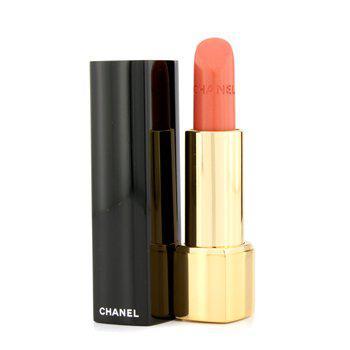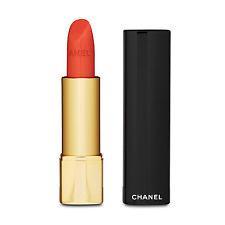The first image is the image on the left, the second image is the image on the right. Examine the images to the left and right. Is the description "There are more than one lipsticks in one of the images." accurate? Answer yes or no. No. The first image is the image on the left, the second image is the image on the right. Given the left and right images, does the statement "One image contains a single lipstick next to its lid, and the other image contains multiple lipsticks next to their lids." hold true? Answer yes or no. No. 